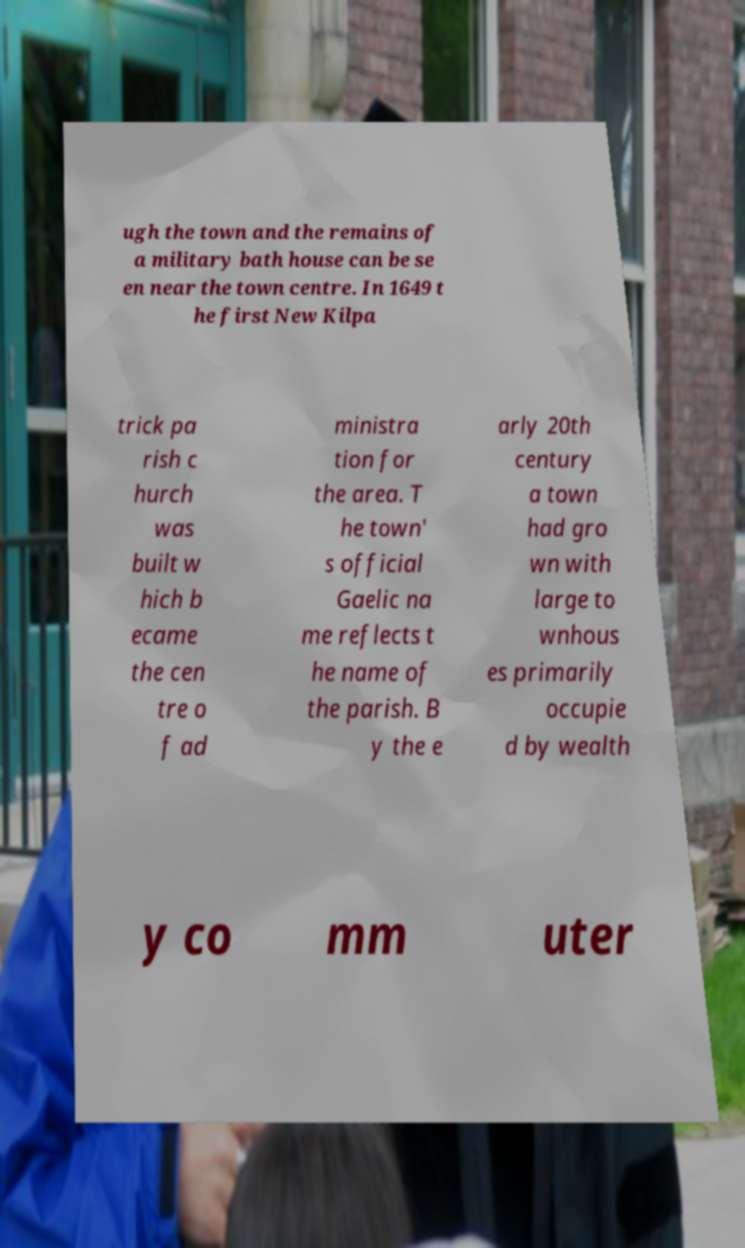Can you accurately transcribe the text from the provided image for me? ugh the town and the remains of a military bath house can be se en near the town centre. In 1649 t he first New Kilpa trick pa rish c hurch was built w hich b ecame the cen tre o f ad ministra tion for the area. T he town' s official Gaelic na me reflects t he name of the parish. B y the e arly 20th century a town had gro wn with large to wnhous es primarily occupie d by wealth y co mm uter 